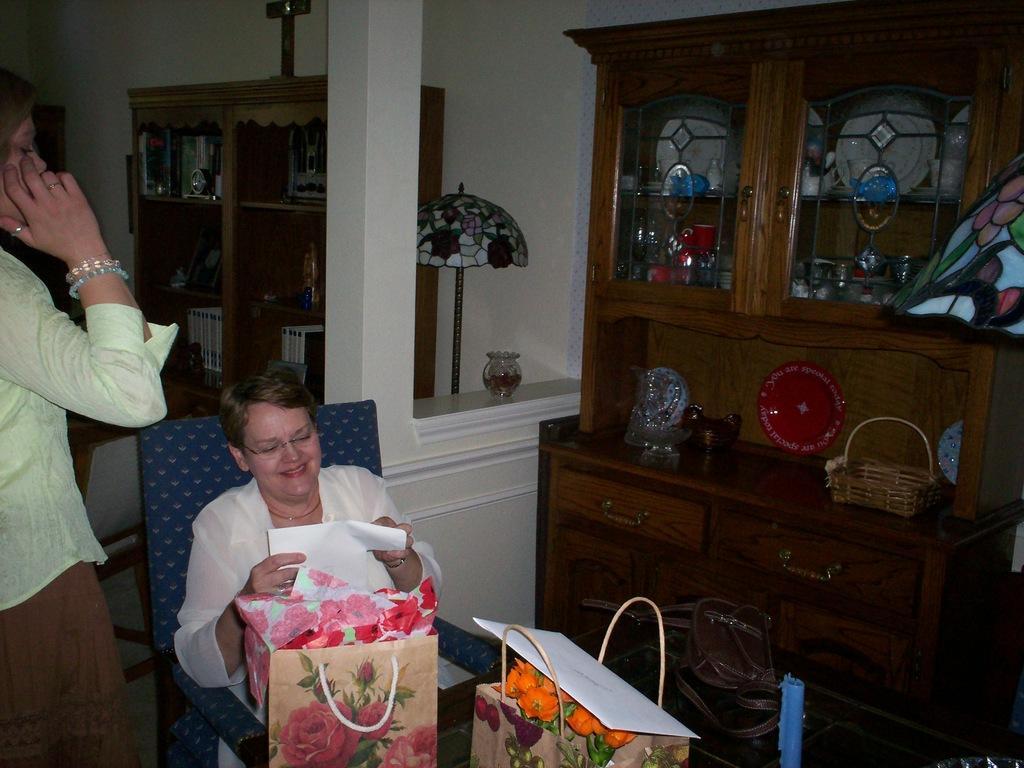Please provide a concise description of this image. In this image we can see a woman is sitting, and smiling, in front here are the bags, and flowers in it, here a person is standing, there are some objects in the cupboard, there is the wall. 